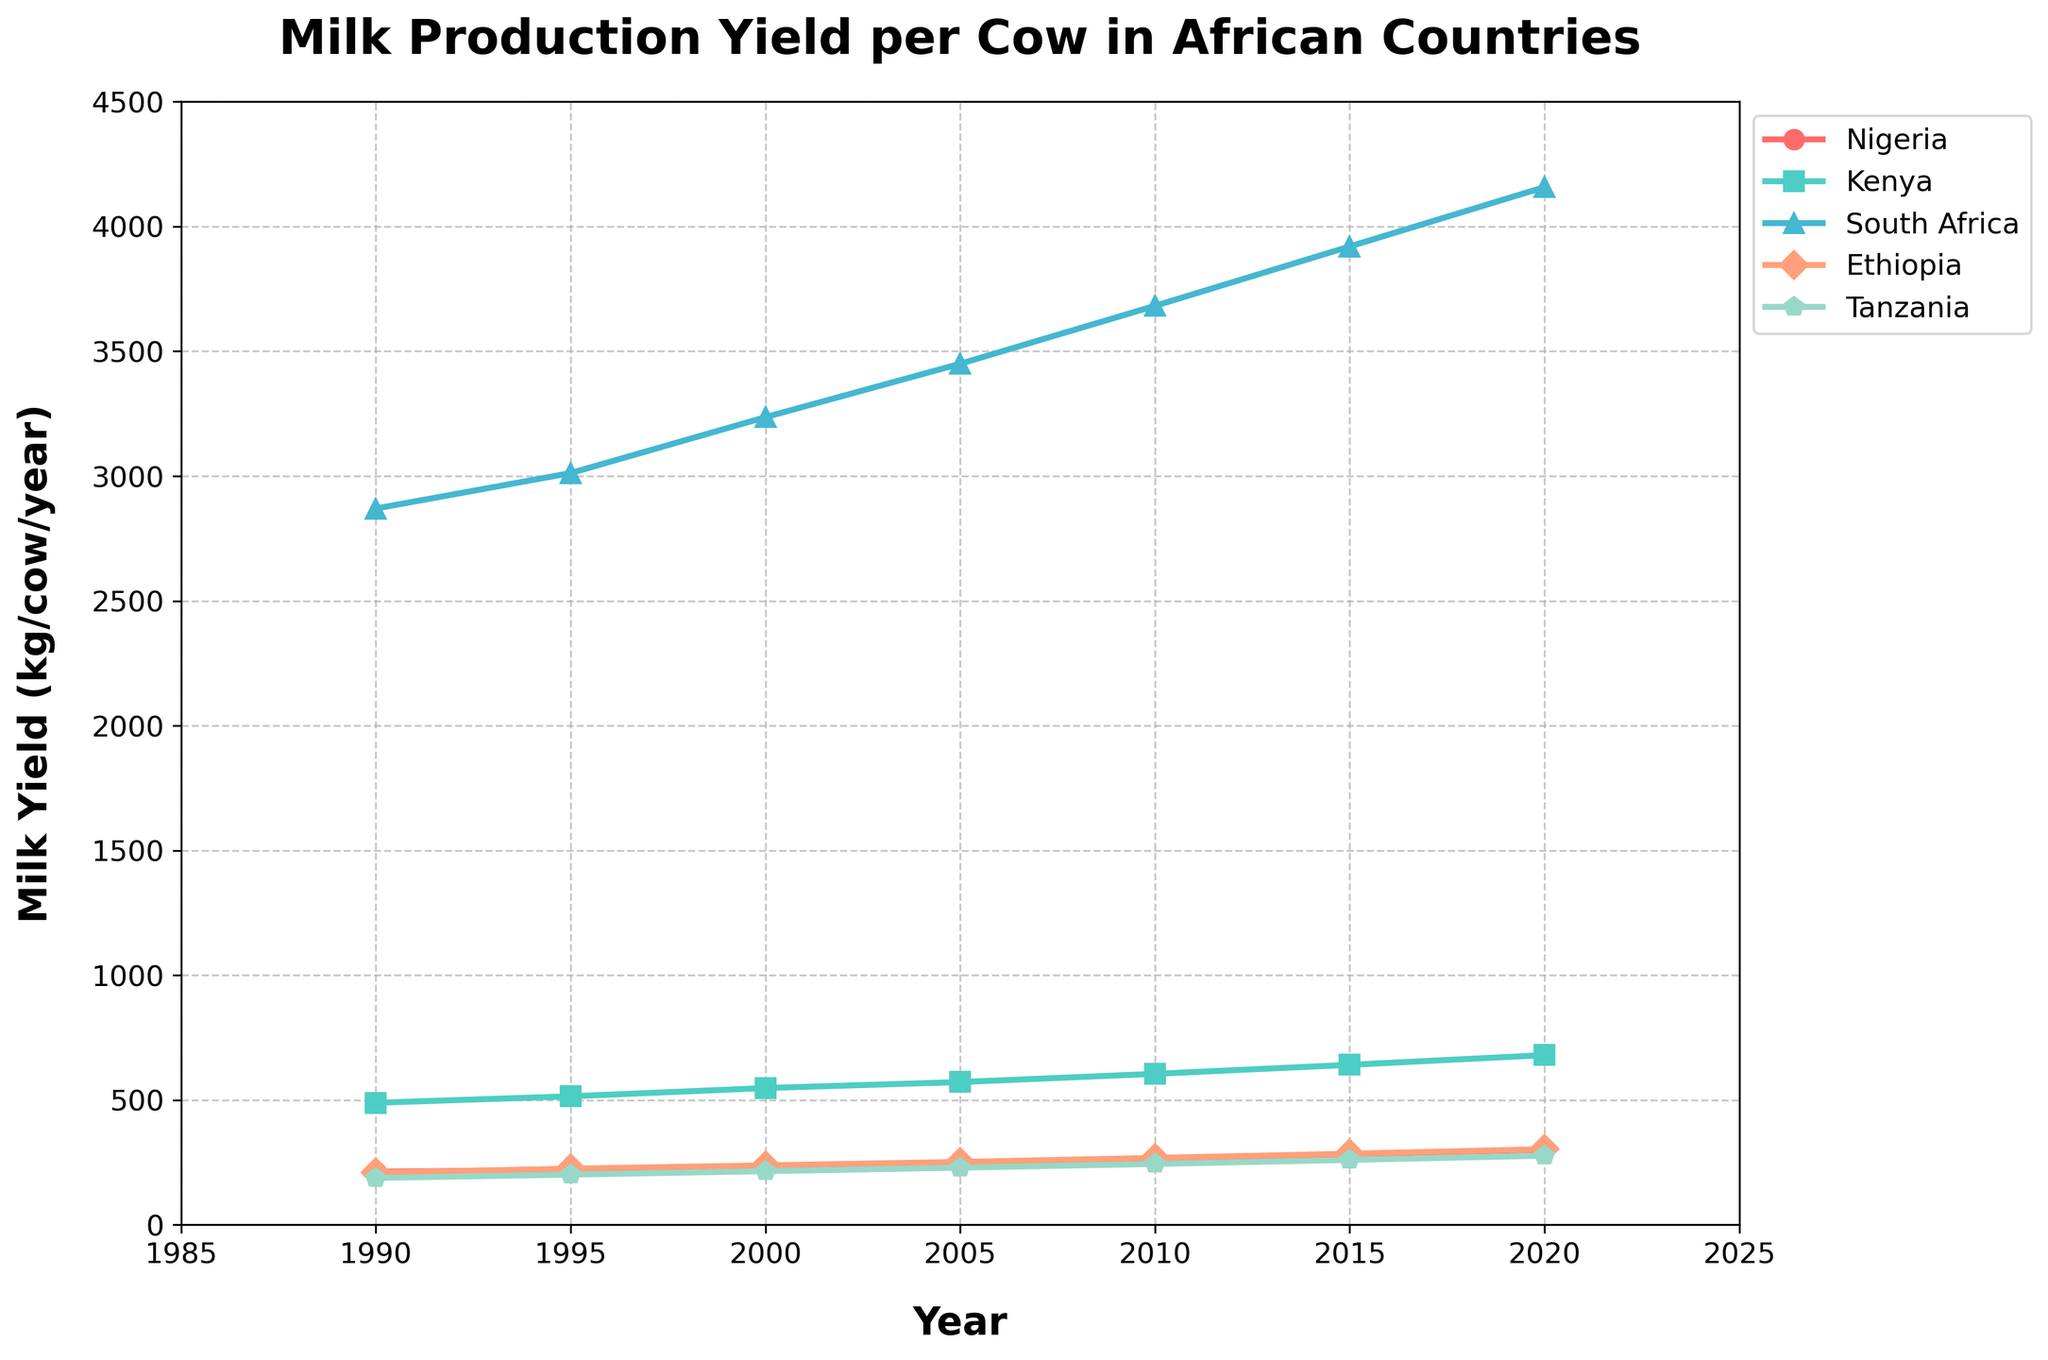Which country had the highest milk yield per cow in 2020? The visual inspection of the lines shows that South Africa has the highest milk yield per cow in 2020, as its line is the highest on the y-axis at that year.
Answer: South Africa How has Nigeria's milk production yield per cow changed from 1990 to 2020? By comparing the points for Nigeria in 1990 and 2020 along the y-axis, we can see the increase from 213 kg to 301 kg per cow per year.
Answer: Increased Which country had the lowest milk yield per cow in 1995? By looking at the lines in 1995, we observe that Ethiopia's line is the lowest on the y-axis at that year.
Answer: Ethiopia What's the difference in milk yield per cow between South Africa and Nigeria in 2020? The 2020 milk yield for South Africa is 4158 kg per cow and for Nigeria is 301 kg per cow. Subtracting these values gives the difference: 4158 - 301.
Answer: 3857 Which country's milk yield per cow experienced the greatest growth from 1990 to 2020? Comparing the starting and ending points of each country's line, South Africa shows the greatest increase, from 2870 kg in 1990 to 4158 kg in 2020 (an increase of 1288 kg).
Answer: South Africa Between Nigeria and Kenya, which country had a higher increase in milk yield per cow from 1990 to 2020? Nigeria increased from 213 kg in 1990 to 301 kg in 2020 (an increase of 88 kg), while Kenya increased from 489 kg to 680 kg (an increase of 191 kg).
Answer: Kenya What was the average milk yield per cow across all five countries in the year 2000? Summing the milk yield values for the year 2000 for all five countries (234 + 548 + 3236 + 238 + 215) and dividing by 5 gives us the average.
Answer: 894.2 Does Tanzania's milk yield per cow ever surpass Ethiopia's from 1990 to 2020? Inspect the points along the lines for Tanzania and Ethiopia throughout the years; Tanzania's line is consistently below Ethiopia's line, meaning it never surpasses Ethiopia's yield.
Answer: No What is the trend of milk yield per cow in Nigeria from 1990 to 2020? Observing the line for Nigeria, it shows a consistent upward slope from 213 kg in 1990 to 301 kg in 2020, indicating a steady increase.
Answer: Steady Increase 